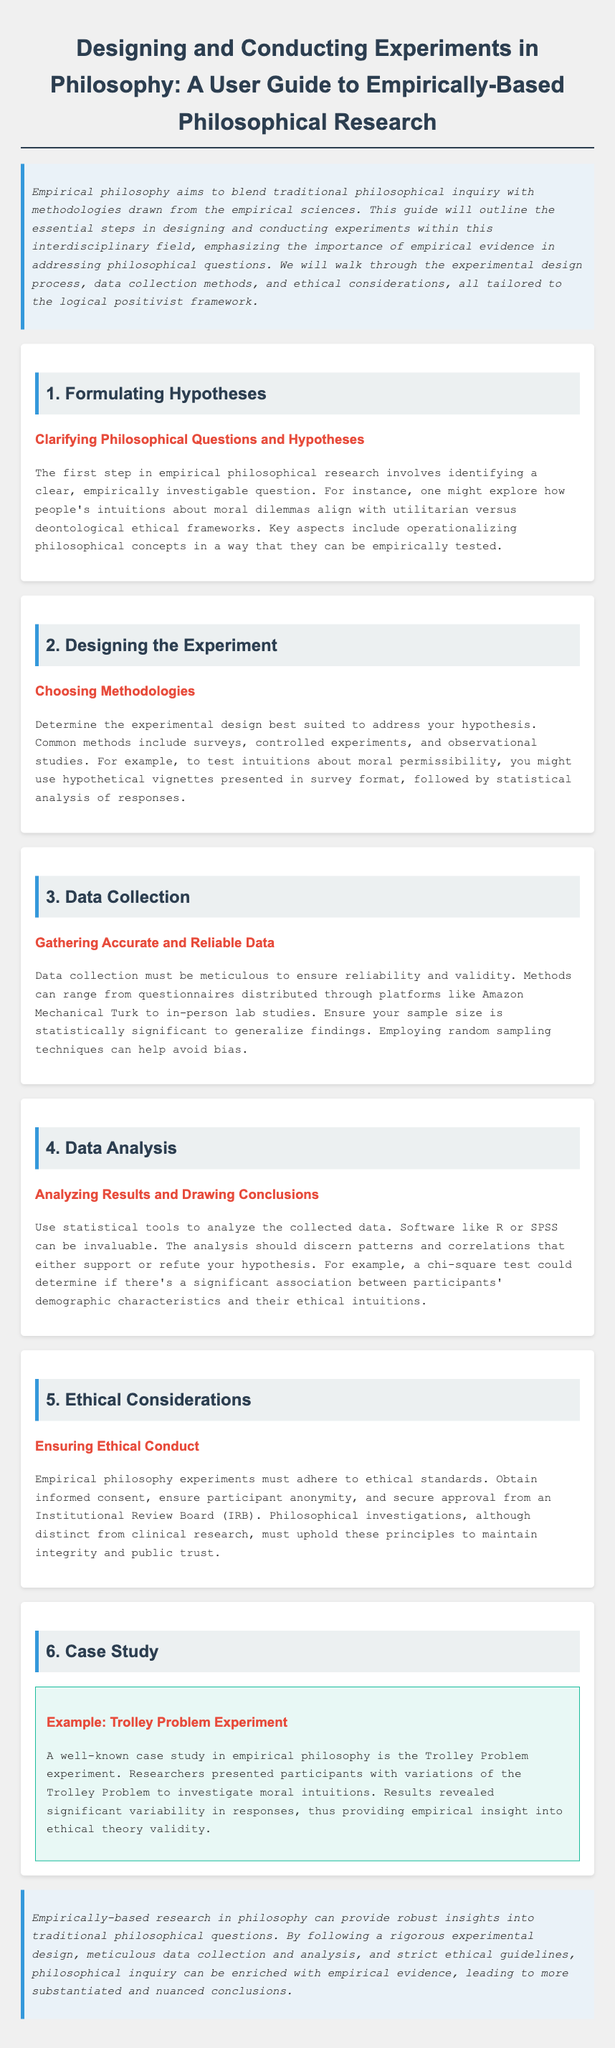what is the title of the document? The title is stated in the main header of the document.
Answer: Designing and Conducting Experiments in Philosophy: A User Guide to Empirically-Based Philosophical Research what is the first step in empirical philosophical research? The document outlines the first step at the beginning of the section on hypotheses.
Answer: Formulating Hypotheses what methodology can be used to test intuitions about moral permissibility? This is mentioned in the section on designing the experiment regarding choosing methodologies.
Answer: Hypothetical vignettes what statistical software is suggested for data analysis? The recommended software is found in the section regarding data analysis.
Answer: R or SPSS how must empirical philosophy experiments ensure ethical conduct? This requirement is outlined in the ethical considerations section.
Answer: Informed consent what kind of problem does the case study focus on? The document specifies the focus of the case study in the section about the trolley problem.
Answer: Trolley Problem what should data collection methods ensure? This expectation is discussed in the data collection section regarding the quality of data.
Answer: Reliability and validity what is the purpose of operationalizing philosophical concepts? The explanation is provided in the section on formulating hypotheses.
Answer: Empirically tested what ethical principle must be maintained according to the guide? The ethical considerations section mentions this principle explicitly.
Answer: Integrity and public trust 